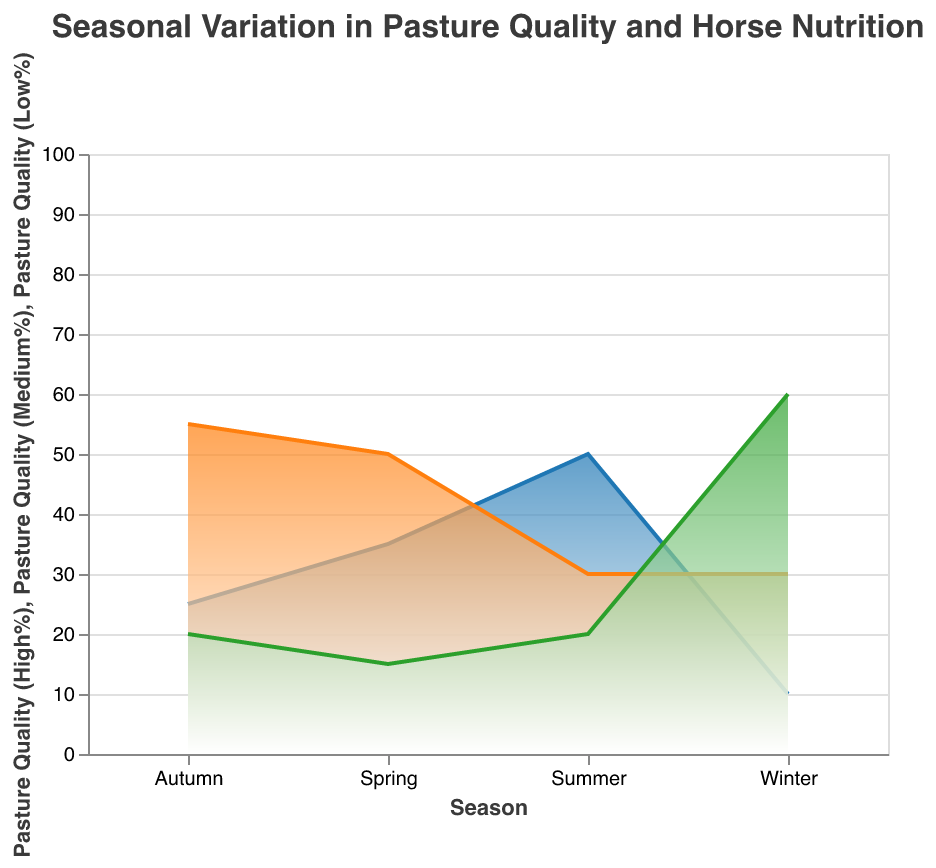What is the title of the figure? The title can be found at the top of the figure, which summarizes the main focus of the data being presented.
Answer: Seasonal Variation in Pasture Quality and Horse Nutrition Which season has the highest percentage of high-quality pasture? Identify the season with the peak value in the "High%" area of the chart, which is indicated by the blue area.
Answer: Summer How does the energy intake (MJ/day) change from Autumn to Winter? Look at the energy intake values in Autumn and Winter and find the difference. The energy intake for Autumn is 85 MJ/day and for Winter is 60 MJ/day. Calculate the change by subtracting the Winter value from the Autumn value.
Answer: Decreases by 25 MJ/day Which season has the lowest protein intake for horses? Examine the values for "Horse Nutrition (Protein g/day)" in all seasons and find the lowest one.
Answer: Winter What is the total pasture quality percentage for medium and low-quality in Summer? Sum the values of "Pasture Quality (Medium%)" and "Pasture Quality (Low%)" for the Summer season. The medium-quality is 30% and the low-quality is 20%. Add these values together.
Answer: 50% How does fiber intake vary between Spring and Winter? Compare the "Horse Nutrition (Fiber g/day)" values for Spring and Winter. Spring has 700 g/day and Winter has 600 g/day. Subtract the Winter value from the Spring value.
Answer: Decreases by 100 g/day Which season shows the greatest variation in pasture quality? Evaluate the range of pasture quality percentages (High%, Medium%, Low%) for each season. The greatest variation is where the difference between the highest and lowest values is largest.
Answer: Winter What is the average energy intake (MJ/day) across all seasons? Add up the energy intake values (90, 80, 85, 60), and then divide by the number of seasons, which is 4.
Answer: 78.75 MJ/day Compare the percentage of low-quality pasture between Spring and Autumn. Which is higher? Look at the "Pasture Quality (Low%)" for both seasons, which are 15% for Spring and 20% for Autumn, and then determine which value is higher.
Answer: Autumn In which season is the proportion of medium-quality pasture the highest? Find the highest value in the "Pasture Quality (Medium%)" area, which is represented by the orange area in the chart.
Answer: Autumn 